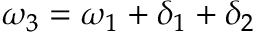Convert formula to latex. <formula><loc_0><loc_0><loc_500><loc_500>\omega _ { 3 } = \omega _ { 1 } + \delta _ { 1 } + \delta _ { 2 }</formula> 